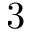Convert formula to latex. <formula><loc_0><loc_0><loc_500><loc_500>3</formula> 